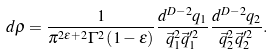Convert formula to latex. <formula><loc_0><loc_0><loc_500><loc_500>d \rho = \frac { 1 } { \pi ^ { 2 \epsilon + 2 } \Gamma ^ { 2 } \left ( 1 - \epsilon \right ) } \frac { d ^ { D - 2 } q _ { 1 } } { \vec { q } _ { 1 } ^ { 2 } \vec { q } _ { 1 } ^ { \prime 2 } } \frac { d ^ { D - 2 } q _ { 2 } } { \vec { q } _ { 2 } ^ { 2 } \vec { q } _ { 2 } ^ { \prime 2 } } .</formula> 